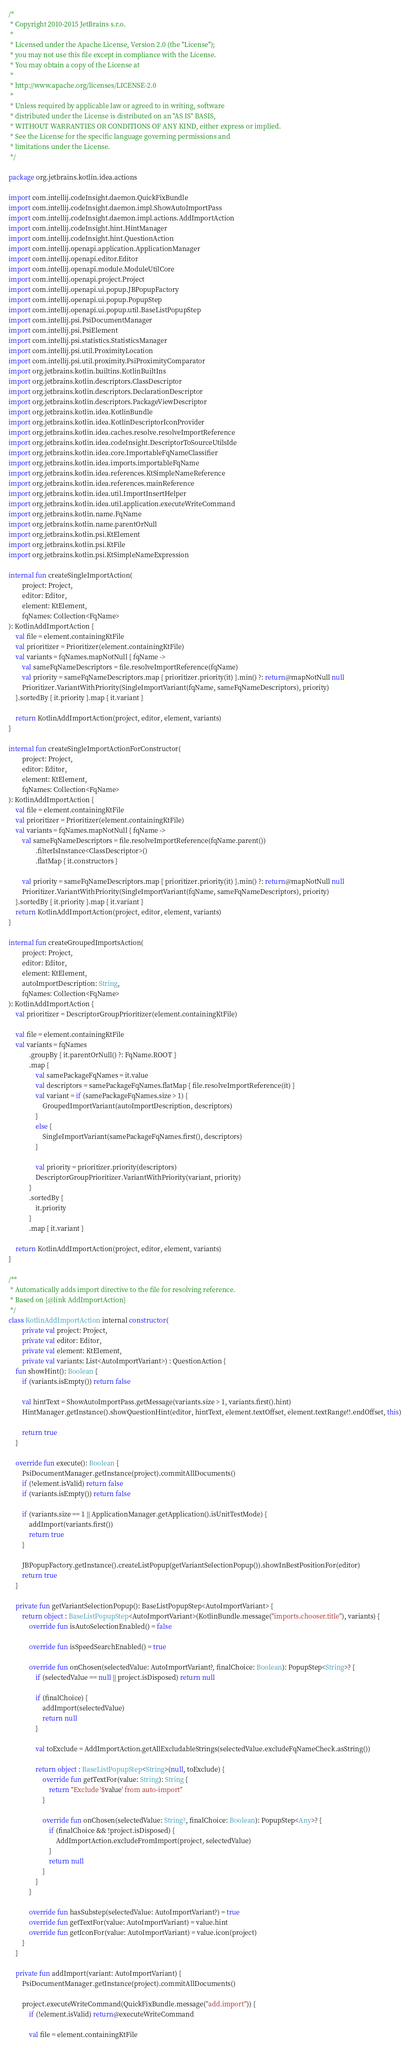Convert code to text. <code><loc_0><loc_0><loc_500><loc_500><_Kotlin_>/*
 * Copyright 2010-2015 JetBrains s.r.o.
 *
 * Licensed under the Apache License, Version 2.0 (the "License");
 * you may not use this file except in compliance with the License.
 * You may obtain a copy of the License at
 *
 * http://www.apache.org/licenses/LICENSE-2.0
 *
 * Unless required by applicable law or agreed to in writing, software
 * distributed under the License is distributed on an "AS IS" BASIS,
 * WITHOUT WARRANTIES OR CONDITIONS OF ANY KIND, either express or implied.
 * See the License for the specific language governing permissions and
 * limitations under the License.
 */

package org.jetbrains.kotlin.idea.actions

import com.intellij.codeInsight.daemon.QuickFixBundle
import com.intellij.codeInsight.daemon.impl.ShowAutoImportPass
import com.intellij.codeInsight.daemon.impl.actions.AddImportAction
import com.intellij.codeInsight.hint.HintManager
import com.intellij.codeInsight.hint.QuestionAction
import com.intellij.openapi.application.ApplicationManager
import com.intellij.openapi.editor.Editor
import com.intellij.openapi.module.ModuleUtilCore
import com.intellij.openapi.project.Project
import com.intellij.openapi.ui.popup.JBPopupFactory
import com.intellij.openapi.ui.popup.PopupStep
import com.intellij.openapi.ui.popup.util.BaseListPopupStep
import com.intellij.psi.PsiDocumentManager
import com.intellij.psi.PsiElement
import com.intellij.psi.statistics.StatisticsManager
import com.intellij.psi.util.ProximityLocation
import com.intellij.psi.util.proximity.PsiProximityComparator
import org.jetbrains.kotlin.builtins.KotlinBuiltIns
import org.jetbrains.kotlin.descriptors.ClassDescriptor
import org.jetbrains.kotlin.descriptors.DeclarationDescriptor
import org.jetbrains.kotlin.descriptors.PackageViewDescriptor
import org.jetbrains.kotlin.idea.KotlinBundle
import org.jetbrains.kotlin.idea.KotlinDescriptorIconProvider
import org.jetbrains.kotlin.idea.caches.resolve.resolveImportReference
import org.jetbrains.kotlin.idea.codeInsight.DescriptorToSourceUtilsIde
import org.jetbrains.kotlin.idea.core.ImportableFqNameClassifier
import org.jetbrains.kotlin.idea.imports.importableFqName
import org.jetbrains.kotlin.idea.references.KtSimpleNameReference
import org.jetbrains.kotlin.idea.references.mainReference
import org.jetbrains.kotlin.idea.util.ImportInsertHelper
import org.jetbrains.kotlin.idea.util.application.executeWriteCommand
import org.jetbrains.kotlin.name.FqName
import org.jetbrains.kotlin.name.parentOrNull
import org.jetbrains.kotlin.psi.KtElement
import org.jetbrains.kotlin.psi.KtFile
import org.jetbrains.kotlin.psi.KtSimpleNameExpression

internal fun createSingleImportAction(
        project: Project,
        editor: Editor,
        element: KtElement,
        fqNames: Collection<FqName>
): KotlinAddImportAction {
    val file = element.containingKtFile
    val prioritizer = Prioritizer(element.containingKtFile)
    val variants = fqNames.mapNotNull { fqName ->
        val sameFqNameDescriptors = file.resolveImportReference(fqName)
        val priority = sameFqNameDescriptors.map { prioritizer.priority(it) }.min() ?: return@mapNotNull null
        Prioritizer.VariantWithPriority(SingleImportVariant(fqName, sameFqNameDescriptors), priority)
    }.sortedBy { it.priority }.map { it.variant }

    return KotlinAddImportAction(project, editor, element, variants)
}

internal fun createSingleImportActionForConstructor(
        project: Project,
        editor: Editor,
        element: KtElement,
        fqNames: Collection<FqName>
): KotlinAddImportAction {
    val file = element.containingKtFile
    val prioritizer = Prioritizer(element.containingKtFile)
    val variants = fqNames.mapNotNull { fqName ->
        val sameFqNameDescriptors = file.resolveImportReference(fqName.parent())
                .filterIsInstance<ClassDescriptor>()
                .flatMap { it.constructors }

        val priority = sameFqNameDescriptors.map { prioritizer.priority(it) }.min() ?: return@mapNotNull null
        Prioritizer.VariantWithPriority(SingleImportVariant(fqName, sameFqNameDescriptors), priority)
    }.sortedBy { it.priority }.map { it.variant }
    return KotlinAddImportAction(project, editor, element, variants)
}

internal fun createGroupedImportsAction(
        project: Project,
        editor: Editor,
        element: KtElement,
        autoImportDescription: String,
        fqNames: Collection<FqName>
): KotlinAddImportAction {
    val prioritizer = DescriptorGroupPrioritizer(element.containingKtFile)

    val file = element.containingKtFile
    val variants = fqNames
            .groupBy { it.parentOrNull() ?: FqName.ROOT }
            .map {
                val samePackageFqNames = it.value
                val descriptors = samePackageFqNames.flatMap { file.resolveImportReference(it) }
                val variant = if (samePackageFqNames.size > 1) {
                    GroupedImportVariant(autoImportDescription, descriptors)
                }
                else {
                    SingleImportVariant(samePackageFqNames.first(), descriptors)
                }

                val priority = prioritizer.priority(descriptors)
                DescriptorGroupPrioritizer.VariantWithPriority(variant, priority)
            }
            .sortedBy {
                it.priority
            }
            .map { it.variant }

    return KotlinAddImportAction(project, editor, element, variants)
}

/**
 * Automatically adds import directive to the file for resolving reference.
 * Based on {@link AddImportAction}
 */
class KotlinAddImportAction internal constructor(
        private val project: Project,
        private val editor: Editor,
        private val element: KtElement,
        private val variants: List<AutoImportVariant>) : QuestionAction {
    fun showHint(): Boolean {
        if (variants.isEmpty()) return false

        val hintText = ShowAutoImportPass.getMessage(variants.size > 1, variants.first().hint)
        HintManager.getInstance().showQuestionHint(editor, hintText, element.textOffset, element.textRange!!.endOffset, this)

        return true
    }

    override fun execute(): Boolean {
        PsiDocumentManager.getInstance(project).commitAllDocuments()
        if (!element.isValid) return false
        if (variants.isEmpty()) return false

        if (variants.size == 1 || ApplicationManager.getApplication().isUnitTestMode) {
            addImport(variants.first())
            return true
        }

        JBPopupFactory.getInstance().createListPopup(getVariantSelectionPopup()).showInBestPositionFor(editor)
        return true
    }

    private fun getVariantSelectionPopup(): BaseListPopupStep<AutoImportVariant> {
        return object : BaseListPopupStep<AutoImportVariant>(KotlinBundle.message("imports.chooser.title"), variants) {
            override fun isAutoSelectionEnabled() = false

            override fun isSpeedSearchEnabled() = true

            override fun onChosen(selectedValue: AutoImportVariant?, finalChoice: Boolean): PopupStep<String>? {
                if (selectedValue == null || project.isDisposed) return null

                if (finalChoice) {
                    addImport(selectedValue)
                    return null
                }

                val toExclude = AddImportAction.getAllExcludableStrings(selectedValue.excludeFqNameCheck.asString())

                return object : BaseListPopupStep<String>(null, toExclude) {
                    override fun getTextFor(value: String): String {
                        return "Exclude '$value' from auto-import"
                    }

                    override fun onChosen(selectedValue: String?, finalChoice: Boolean): PopupStep<Any>? {
                        if (finalChoice && !project.isDisposed) {
                            AddImportAction.excludeFromImport(project, selectedValue)
                        }
                        return null
                    }
                }
            }

            override fun hasSubstep(selectedValue: AutoImportVariant?) = true
            override fun getTextFor(value: AutoImportVariant) = value.hint
            override fun getIconFor(value: AutoImportVariant) = value.icon(project)
        }
    }

    private fun addImport(variant: AutoImportVariant) {
        PsiDocumentManager.getInstance(project).commitAllDocuments()

        project.executeWriteCommand(QuickFixBundle.message("add.import")) {
            if (!element.isValid) return@executeWriteCommand

            val file = element.containingKtFile
</code> 